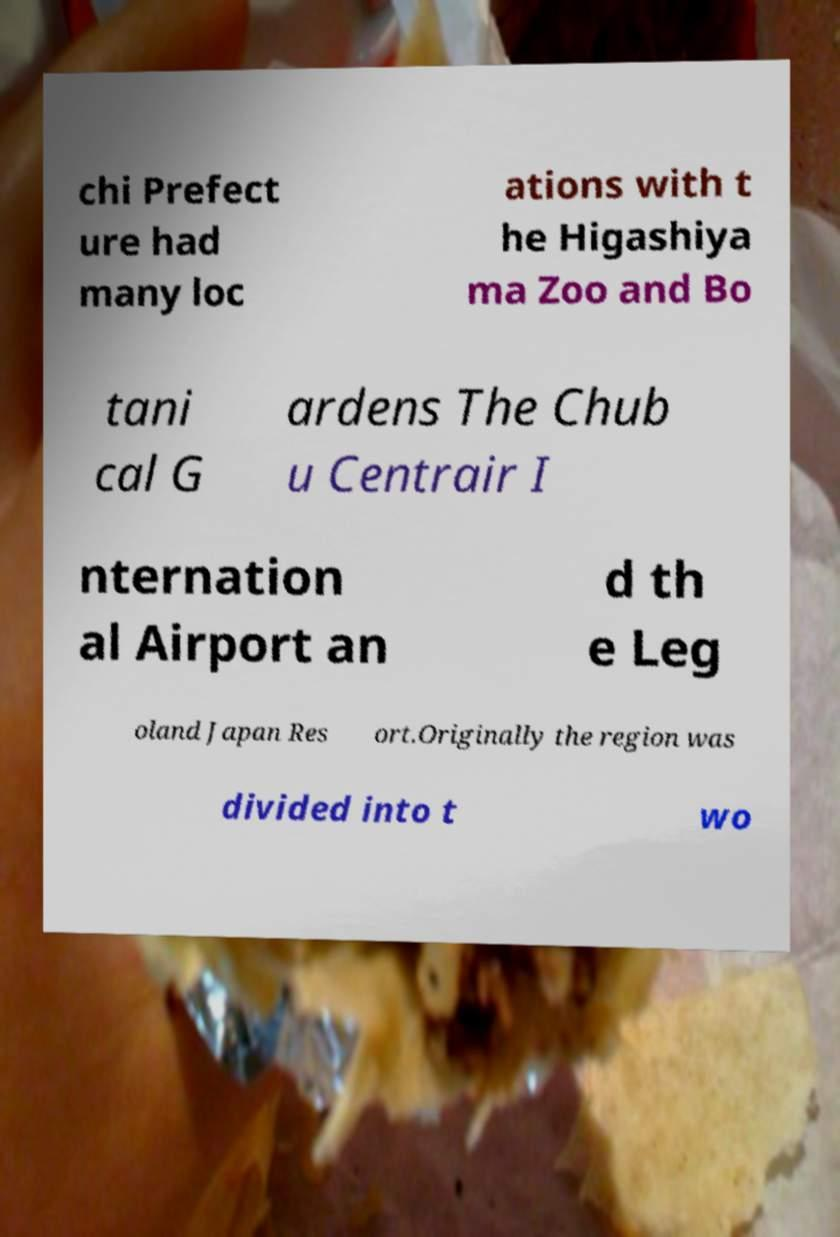Please read and relay the text visible in this image. What does it say? chi Prefect ure had many loc ations with t he Higashiya ma Zoo and Bo tani cal G ardens The Chub u Centrair I nternation al Airport an d th e Leg oland Japan Res ort.Originally the region was divided into t wo 